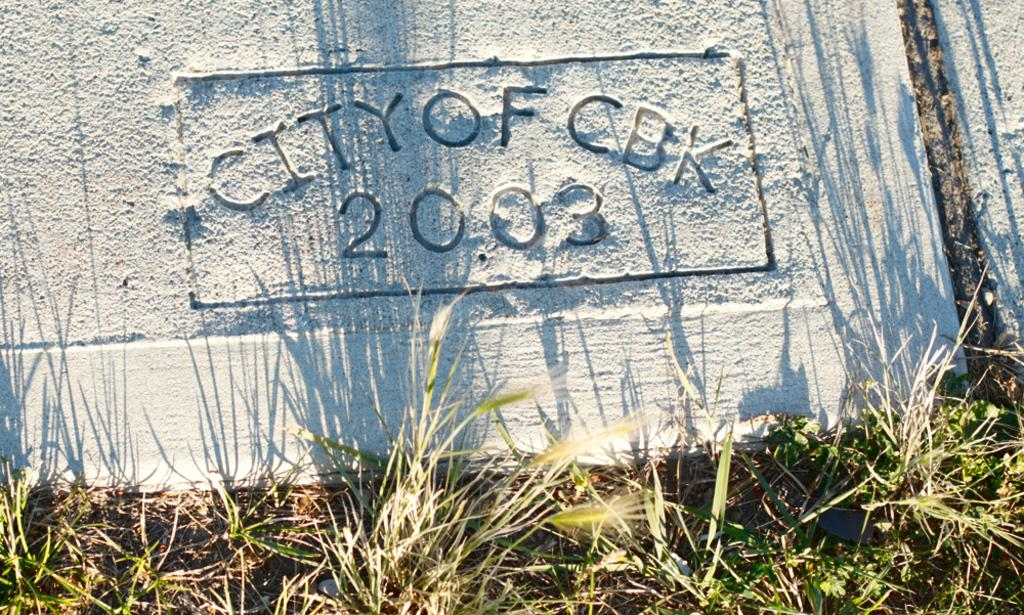What type of vegetation is present in the image? There is grass in the image. Can you describe any other objects or features in the image? There is text on a stone in the image. What type of nut can be seen on the hydrant in the image? There is no hydrant or nut present in the image. What key is used to unlock the text on the stone in the image? There is no key or lock associated with the text on the stone in the image. 